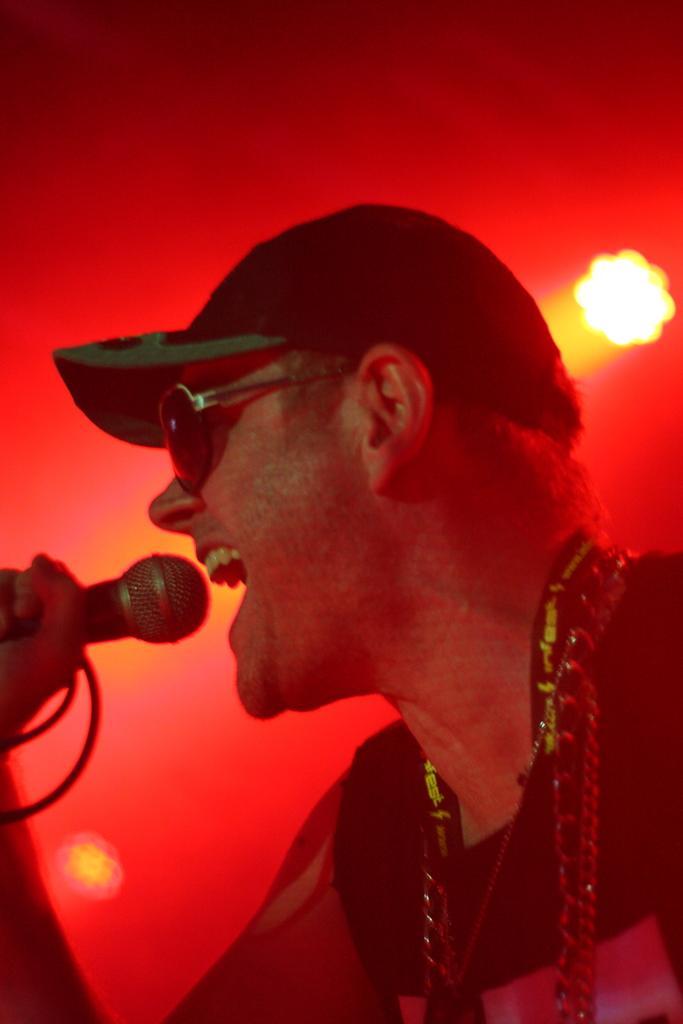How would you summarize this image in a sentence or two? In the picture I can see a person wearing cap, goggles holding microphone in his hands and in the background there are some lights. 